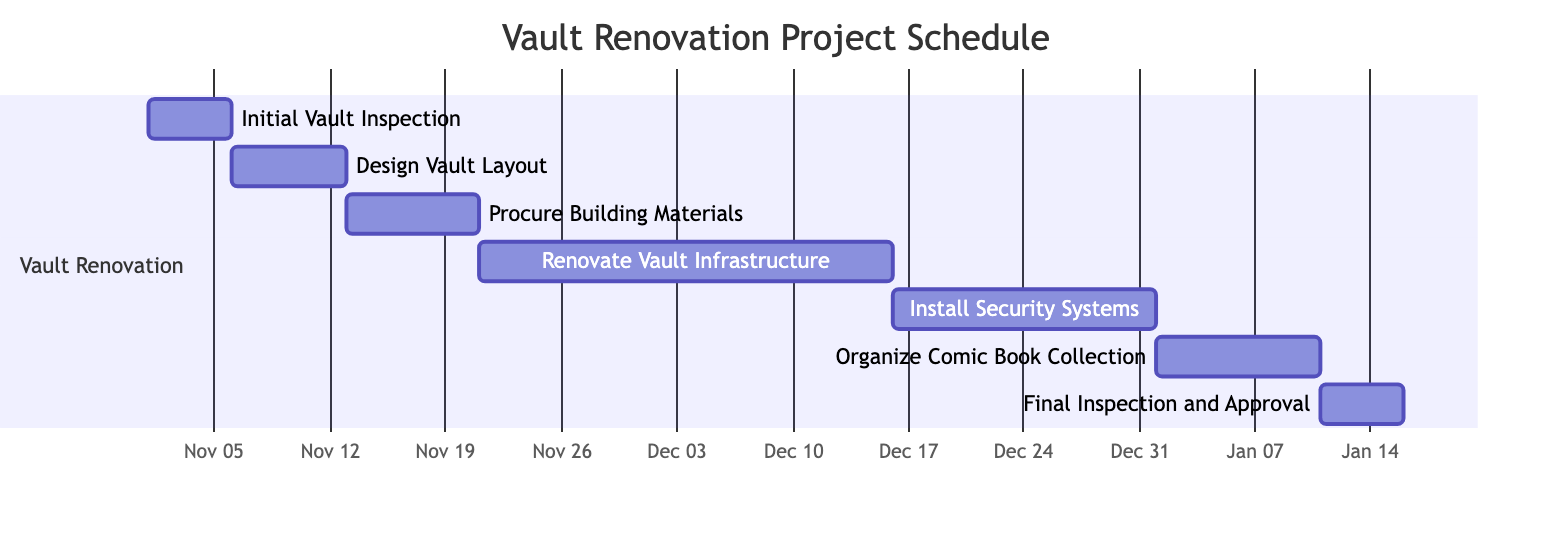What is the duration of the "Design Vault Layout" task? The duration of a task is explicitly provided in the data for that specific task. In this case, looking at the "Design Vault Layout" task, it states the duration is 7 days.
Answer: 7 days Which task starts immediately after the "Initial Vault Inspection"? After examining the timeline of tasks, "Design Vault Layout" follows "Initial Vault Inspection," with its start date immediately after the end date of the previous task.
Answer: Design Vault Layout How many days are allocated for the "Renovate Vault Infrastructure" task? The duration for "Renovate Vault Infrastructure" is provided in the data. It's mentioned to have a duration of 25 days.
Answer: 25 days What is the end date of the "Install Security Systems" task? By referring to the task details, the end date for "Install Security Systems" is listed as December 31, 2023.
Answer: 2023-12-31 Which task has the longest duration? By comparing the duration of all tasks, we notice that the "Renovate Vault Infrastructure" has the longest span, totaling 25 days, while others range from 5 to 16 days.
Answer: Renovate Vault Infrastructure List the tasks that occur in December. By examining the timeframes of each task, both "Install Security Systems" and "Renovate Vault Infrastructure" occur in December, specifically with the former concluding that month.
Answer: Install Security Systems, Renovate Vault Infrastructure What is the total number of tasks in this project? We tally the number of tasks provided in the data. Each task has been outlined, and upon counting them, we find there are 7 tasks in total.
Answer: 7 What task follows the "Procure Building Materials" in the timeline? Analyzing the sequence of tasks, "Renovate Vault Infrastructure" directly follows "Procure Building Materials" based on their respective start dates.
Answer: Renovate Vault Infrastructure How many tasks are completed before the "Final Inspection and Approval"? To determine how many tasks finish before "Final Inspection and Approval," we look at the start dates. Tasks completed beforehand include "Initial Vault Inspection," "Design Vault Layout," "Procure Building Materials," "Renovate Vault Infrastructure," and "Install Security Systems," totaling 5 tasks.
Answer: 5 